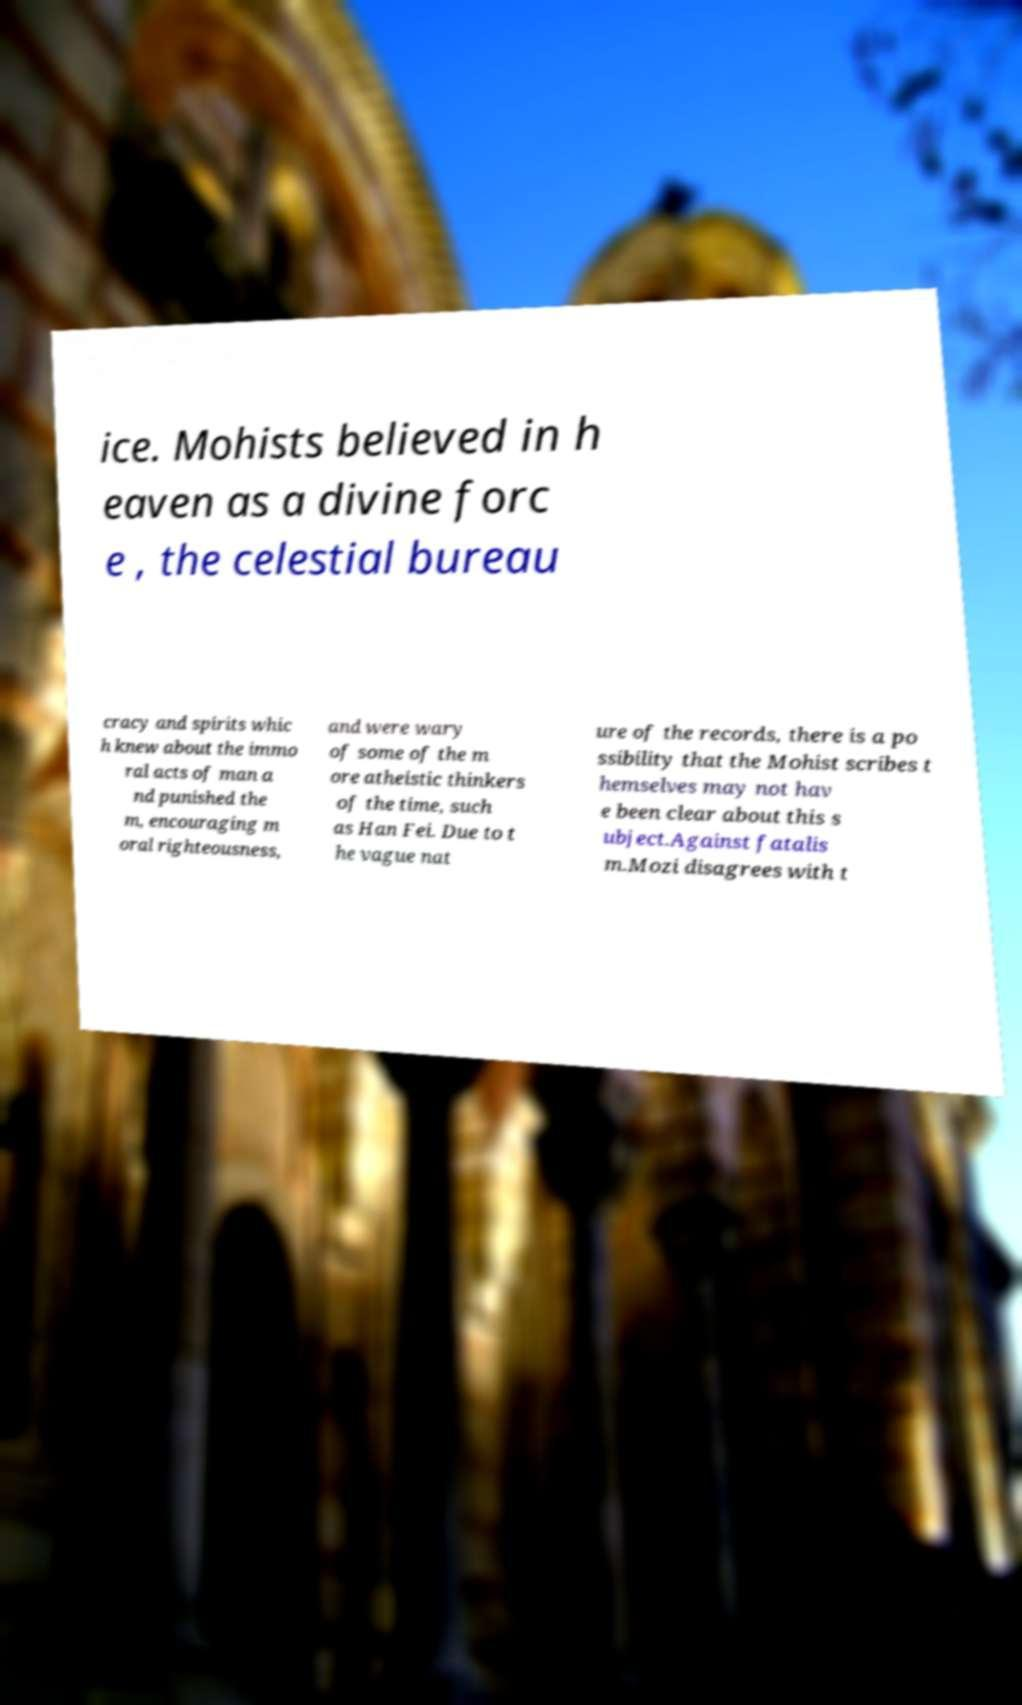What messages or text are displayed in this image? I need them in a readable, typed format. ice. Mohists believed in h eaven as a divine forc e , the celestial bureau cracy and spirits whic h knew about the immo ral acts of man a nd punished the m, encouraging m oral righteousness, and were wary of some of the m ore atheistic thinkers of the time, such as Han Fei. Due to t he vague nat ure of the records, there is a po ssibility that the Mohist scribes t hemselves may not hav e been clear about this s ubject.Against fatalis m.Mozi disagrees with t 